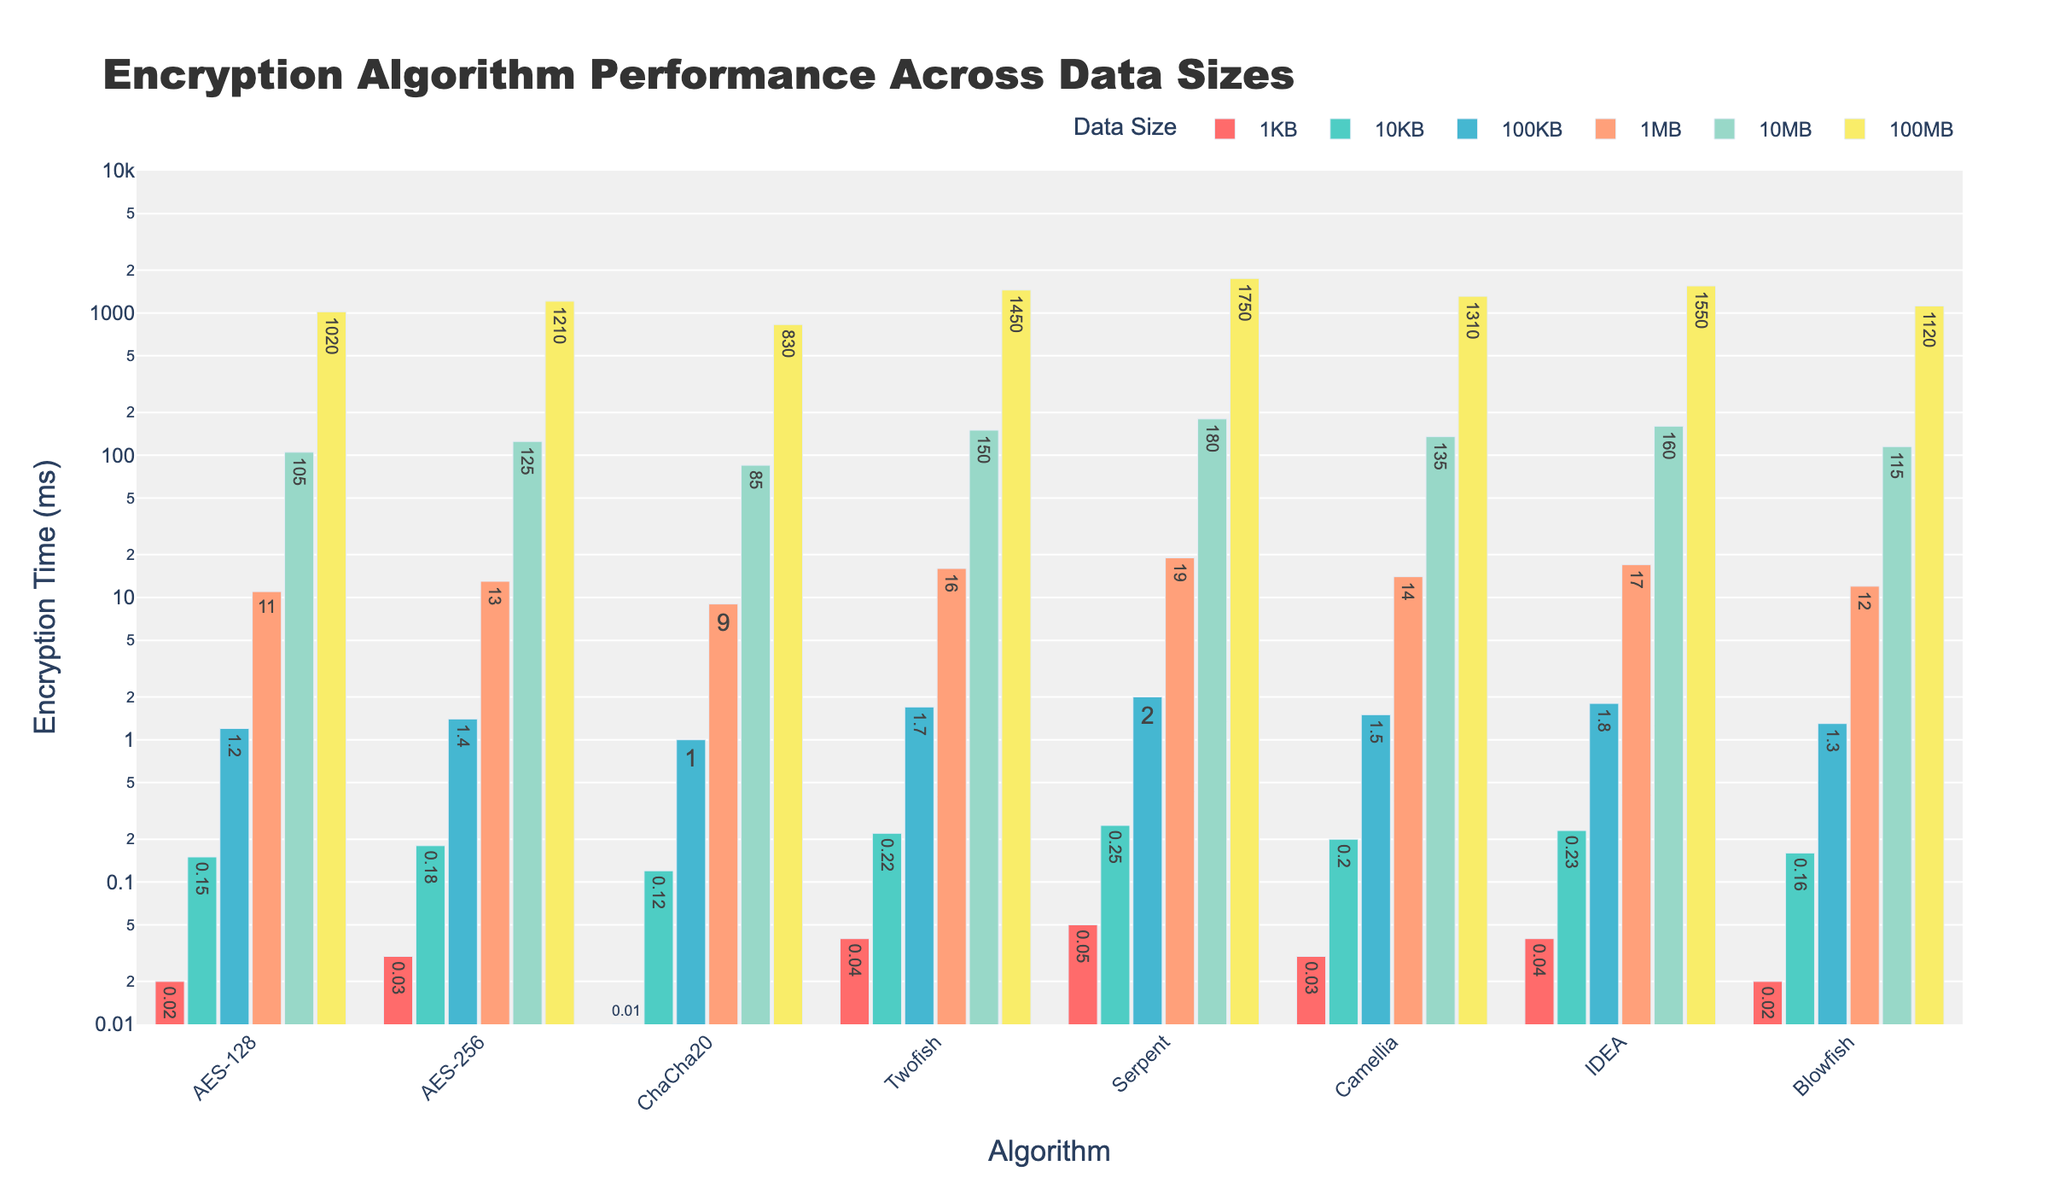Which encryption algorithm has the highest performance for 1KB data size? Look at the bar for each algorithm corresponding to 1KB. ChaCha20 has the shortest bar, indicating the smallest encryption time
Answer: ChaCha20 Which algorithm takes the longest time to encrypt 100MB of data? Observe the bars for each algorithm corresponding to 100MB. Serpent has the tallest bar
Answer: Serpent For 10KB data size, which algorithm performs better: AES-128 or Blowfish? Compare the heights of the 10KB bars for AES-128 and Blowfish. AES-128's bar is shorter
Answer: AES-128 What is the difference in encryption time between Twofish and Camellia for 1MB data size? Subtract the height of the Camellia bar from the height of the Twofish bar for 1MB (16 - 14)
Answer: 2 ms Which data size has the most significant performance difference between AES-128 and AES-256? Compare the size differences for each data size. 100MB shows the most noticeable performance difference
Answer: 100MB Which algorithm demonstrates the most consistent performance across all data sizes? Analyze the bars' heights across all sizes for each algorithm. ChaCha20's bars show relatively small and consistent heights
Answer: ChaCha20 What is the average encryption time for Camellia for the data sizes 1KB, 10KB, and 100KB? Add the times for 1KB, 10KB, and 100KB for Camellia, then divide by 3: (0.03 + 0.20 + 1.5) / 3 = 1.73 / 3
Answer: 0.5767 ms Which algorithms have faster encryption times than AES-256 for 10MB data size? Compare the bars of all algorithms for 10MB with AES-256. ChaCha20, and Blowfish have shorter bars
Answer: ChaCha20, Blowfish Which encryption algorithm shows the highest time increase when moving from 1KB to 100MB? Find the difference for each algorithm between 1KB and 100MB, then determine the largest difference. Serpent has the largest increase (1750 - 0.05)
Answer: Serpent 